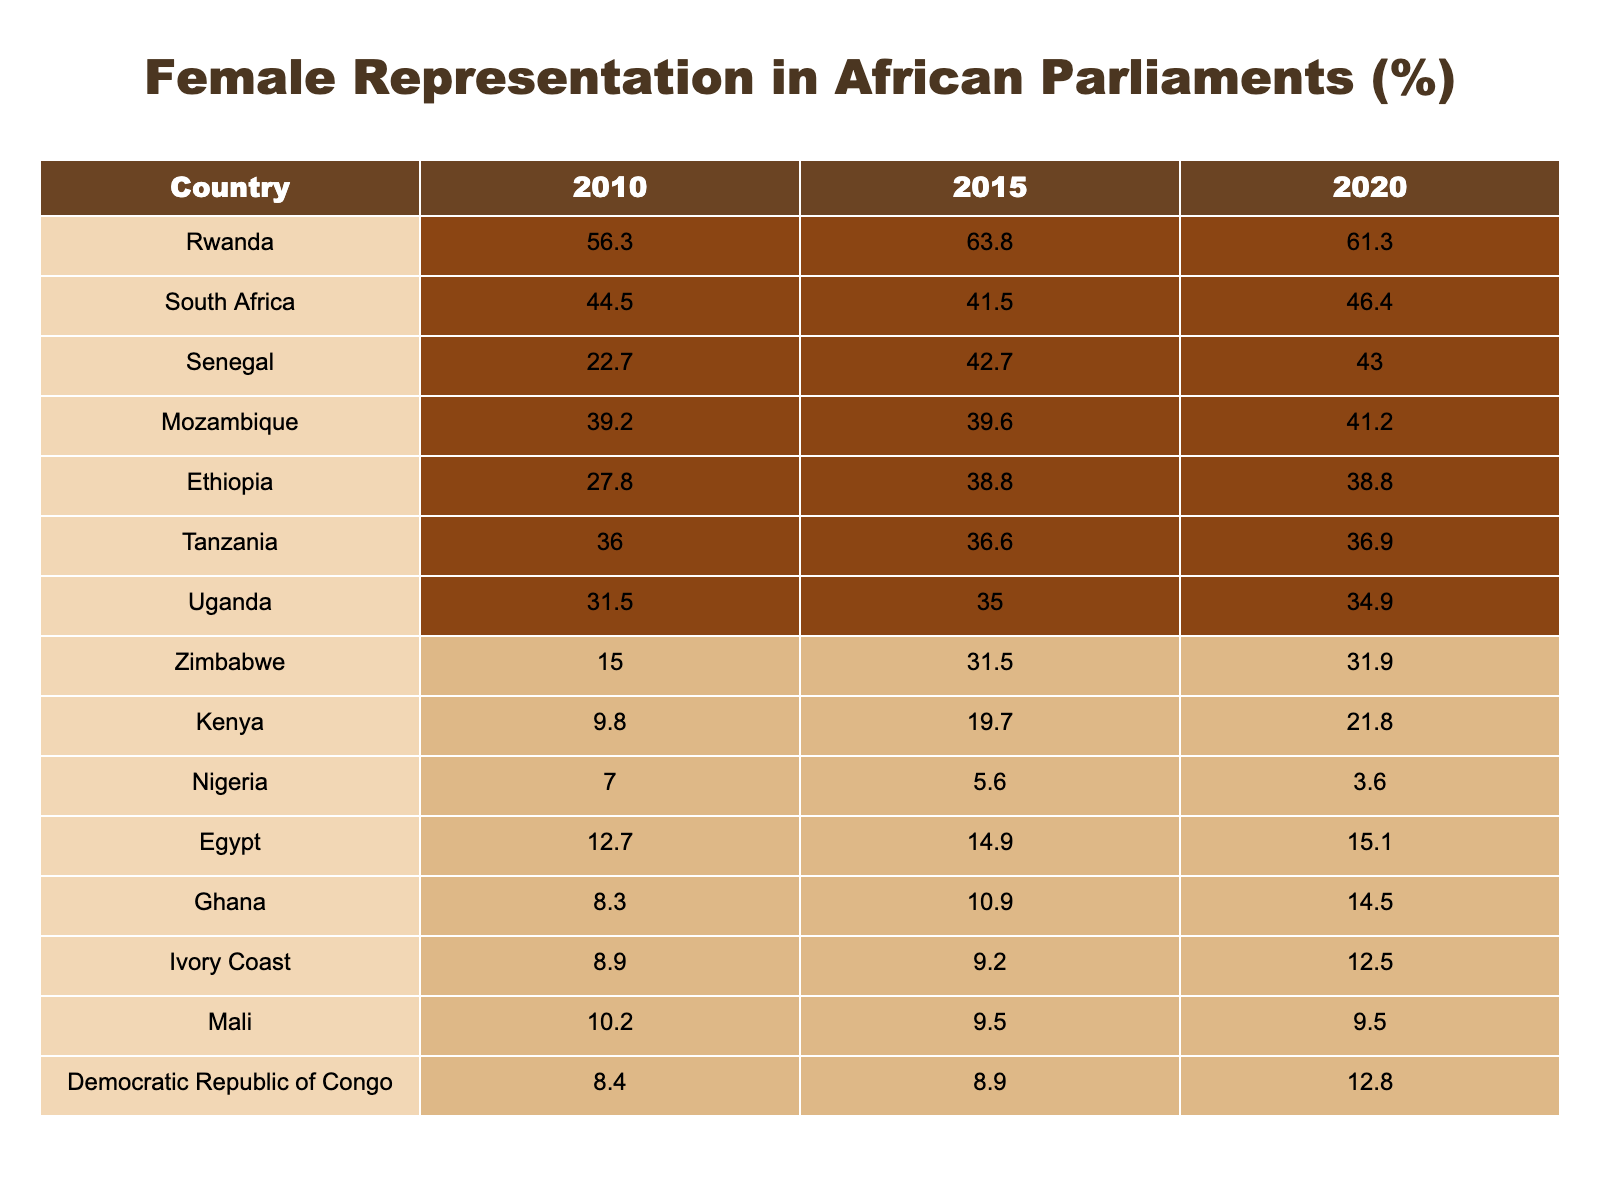What is the female representation percentage in Rwanda in 2020? Referring to the table, the value under Rwanda for the year 2020 is 61.3%.
Answer: 61.3% Which country had the lowest female representation in 2010? Looking at the values in the 2010 column, Nigeria has the lowest percentage at 7.0%.
Answer: Nigeria What was the difference in female representation percentage for South Africa between 2015 and 2020? South Africa's representation in 2015 is 41.5% and in 2020 is 46.4%. The difference is 46.4 - 41.5 = 4.9%.
Answer: 4.9% Which two countries saw an increase in female representation from 2010 to 2020? By comparing the values in the table for both years, Rwanda (56.3 to 61.3) and Senegal (22.7 to 43.0) both show an increase.
Answer: Rwanda and Senegal What is the median female representation across all countries in 2020? First, arrange the 2020 values: 3.6, 12.5, 14.5, 15.1, 21.8, 31.9, 34.9, 36.9, 38.8, 41.2, 43.0, 46.4, 61.3. There are 13 data points, and the median is the 7th value, which is 36.9%.
Answer: 36.9% Is the female representation in Egypt higher in 2015 compared to 2010? Checking the values for Egypt, in 2010 it was 12.7% and in 2015 it is 14.9%. Since 14.9 > 12.7, the statement is true.
Answer: Yes Which country experienced the largest decrease in female representation from 2015 to 2020? Examine the 2015 and 2020 values: Nigeria decreases from 5.6% to 3.6%, a drop of 2.0%. Other countries are compared similarly, but Nigeria has the largest drop.
Answer: Nigeria What percentage of female representation did Zimbabwe achieve in 2015? The table shows that Zimbabwe's female representation in 2015 is 31.5%.
Answer: 31.5% If you average the female representation percentages for Kenya over the three years, what do you get? Adding Kenya's percentages: 9.8 + 19.7 + 21.8 = 51.3. Dividing by 3 gives the average: 51.3 / 3 = 17.1%.
Answer: 17.1% Which country had higher female representation in 2020, Uganda or Mozambique? Checking the 2020 values, Uganda is 34.9% and Mozambique is 41.2%. Since 41.2% > 34.9%, Mozambique had higher representation.
Answer: Mozambique Is the percentage of female representation in Mali constant over the years? Looking at the table, Mali's values are 10.2% in 2010, 9.5% in 2015, and 9.5% in 2020. Since there is a decrease in 2015, the statement is false.
Answer: No 